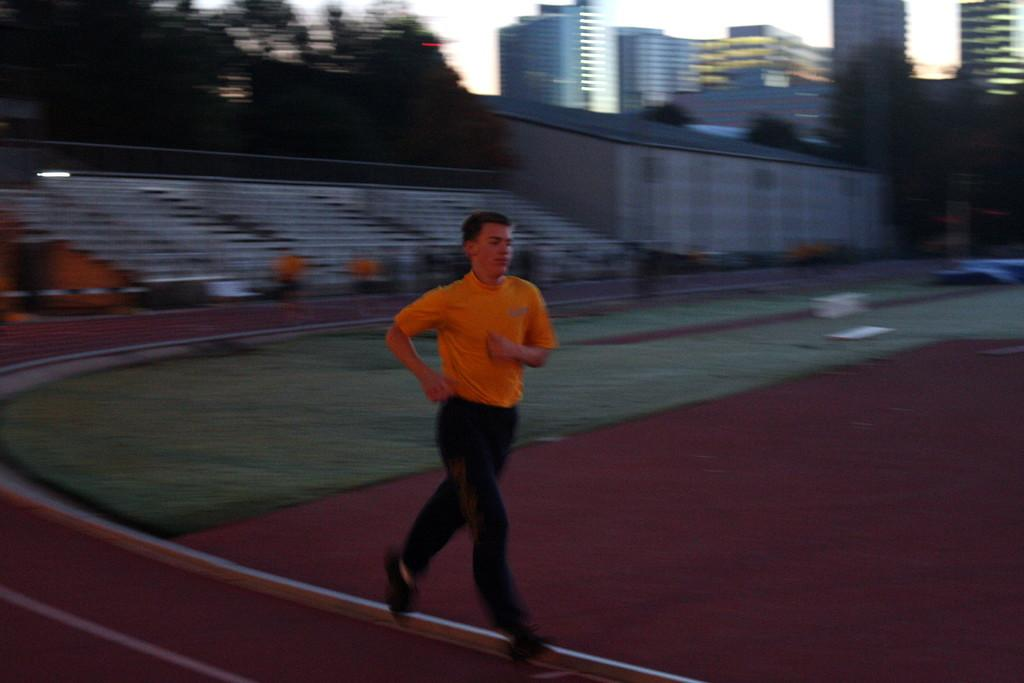What is the person in the image wearing? The person is wearing an orange t-shirt in the image. What is the person doing in the image? The person is running in the image. Where is the person running? The person is running on the ground of a stadium in the image. What can be seen in the background of the image? There are trees, buildings, and the sky visible in the background of the image. How many seagulls can be seen flying over the stadium in the image? There are no seagulls visible in the image; it is set in a stadium with trees, buildings, and the sky in the background. 